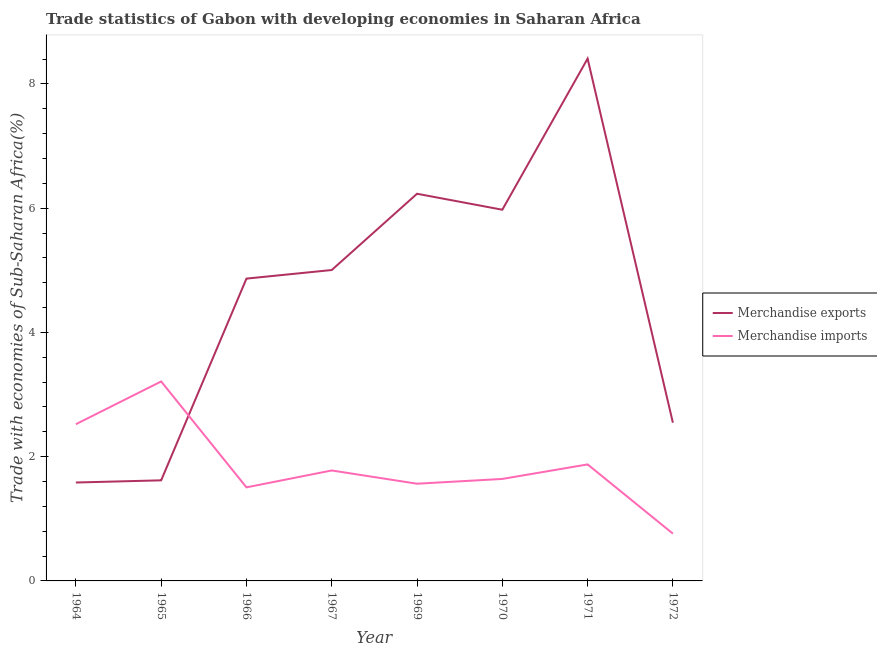How many different coloured lines are there?
Ensure brevity in your answer.  2. Does the line corresponding to merchandise exports intersect with the line corresponding to merchandise imports?
Offer a terse response. Yes. What is the merchandise imports in 1972?
Provide a succinct answer. 0.76. Across all years, what is the maximum merchandise exports?
Give a very brief answer. 8.41. Across all years, what is the minimum merchandise exports?
Your answer should be very brief. 1.58. In which year was the merchandise exports maximum?
Offer a very short reply. 1971. What is the total merchandise imports in the graph?
Keep it short and to the point. 14.86. What is the difference between the merchandise imports in 1964 and that in 1971?
Give a very brief answer. 0.65. What is the difference between the merchandise imports in 1964 and the merchandise exports in 1969?
Provide a succinct answer. -3.71. What is the average merchandise exports per year?
Your response must be concise. 4.53. In the year 1964, what is the difference between the merchandise exports and merchandise imports?
Offer a terse response. -0.94. What is the ratio of the merchandise imports in 1970 to that in 1972?
Your answer should be very brief. 2.16. Is the merchandise exports in 1971 less than that in 1972?
Make the answer very short. No. Is the difference between the merchandise exports in 1966 and 1971 greater than the difference between the merchandise imports in 1966 and 1971?
Ensure brevity in your answer.  No. What is the difference between the highest and the second highest merchandise imports?
Your answer should be compact. 0.69. What is the difference between the highest and the lowest merchandise exports?
Keep it short and to the point. 6.82. In how many years, is the merchandise exports greater than the average merchandise exports taken over all years?
Your answer should be compact. 5. Does the merchandise exports monotonically increase over the years?
Your answer should be compact. No. Is the merchandise imports strictly greater than the merchandise exports over the years?
Provide a short and direct response. No. Is the merchandise imports strictly less than the merchandise exports over the years?
Your answer should be compact. No. Are the values on the major ticks of Y-axis written in scientific E-notation?
Ensure brevity in your answer.  No. Does the graph contain grids?
Keep it short and to the point. No. How many legend labels are there?
Keep it short and to the point. 2. What is the title of the graph?
Offer a terse response. Trade statistics of Gabon with developing economies in Saharan Africa. What is the label or title of the Y-axis?
Give a very brief answer. Trade with economies of Sub-Saharan Africa(%). What is the Trade with economies of Sub-Saharan Africa(%) in Merchandise exports in 1964?
Provide a succinct answer. 1.58. What is the Trade with economies of Sub-Saharan Africa(%) in Merchandise imports in 1964?
Your answer should be very brief. 2.52. What is the Trade with economies of Sub-Saharan Africa(%) of Merchandise exports in 1965?
Your response must be concise. 1.62. What is the Trade with economies of Sub-Saharan Africa(%) of Merchandise imports in 1965?
Make the answer very short. 3.21. What is the Trade with economies of Sub-Saharan Africa(%) in Merchandise exports in 1966?
Your answer should be very brief. 4.87. What is the Trade with economies of Sub-Saharan Africa(%) of Merchandise imports in 1966?
Offer a terse response. 1.51. What is the Trade with economies of Sub-Saharan Africa(%) of Merchandise exports in 1967?
Offer a very short reply. 5. What is the Trade with economies of Sub-Saharan Africa(%) of Merchandise imports in 1967?
Give a very brief answer. 1.78. What is the Trade with economies of Sub-Saharan Africa(%) in Merchandise exports in 1969?
Make the answer very short. 6.23. What is the Trade with economies of Sub-Saharan Africa(%) in Merchandise imports in 1969?
Provide a short and direct response. 1.56. What is the Trade with economies of Sub-Saharan Africa(%) in Merchandise exports in 1970?
Give a very brief answer. 5.97. What is the Trade with economies of Sub-Saharan Africa(%) of Merchandise imports in 1970?
Ensure brevity in your answer.  1.64. What is the Trade with economies of Sub-Saharan Africa(%) of Merchandise exports in 1971?
Give a very brief answer. 8.41. What is the Trade with economies of Sub-Saharan Africa(%) in Merchandise imports in 1971?
Keep it short and to the point. 1.88. What is the Trade with economies of Sub-Saharan Africa(%) of Merchandise exports in 1972?
Offer a very short reply. 2.55. What is the Trade with economies of Sub-Saharan Africa(%) of Merchandise imports in 1972?
Offer a very short reply. 0.76. Across all years, what is the maximum Trade with economies of Sub-Saharan Africa(%) of Merchandise exports?
Ensure brevity in your answer.  8.41. Across all years, what is the maximum Trade with economies of Sub-Saharan Africa(%) in Merchandise imports?
Ensure brevity in your answer.  3.21. Across all years, what is the minimum Trade with economies of Sub-Saharan Africa(%) in Merchandise exports?
Offer a terse response. 1.58. Across all years, what is the minimum Trade with economies of Sub-Saharan Africa(%) in Merchandise imports?
Provide a short and direct response. 0.76. What is the total Trade with economies of Sub-Saharan Africa(%) in Merchandise exports in the graph?
Your response must be concise. 36.23. What is the total Trade with economies of Sub-Saharan Africa(%) of Merchandise imports in the graph?
Your response must be concise. 14.86. What is the difference between the Trade with economies of Sub-Saharan Africa(%) in Merchandise exports in 1964 and that in 1965?
Offer a very short reply. -0.04. What is the difference between the Trade with economies of Sub-Saharan Africa(%) in Merchandise imports in 1964 and that in 1965?
Your answer should be very brief. -0.69. What is the difference between the Trade with economies of Sub-Saharan Africa(%) of Merchandise exports in 1964 and that in 1966?
Make the answer very short. -3.28. What is the difference between the Trade with economies of Sub-Saharan Africa(%) of Merchandise imports in 1964 and that in 1966?
Provide a short and direct response. 1.02. What is the difference between the Trade with economies of Sub-Saharan Africa(%) of Merchandise exports in 1964 and that in 1967?
Give a very brief answer. -3.42. What is the difference between the Trade with economies of Sub-Saharan Africa(%) in Merchandise imports in 1964 and that in 1967?
Make the answer very short. 0.74. What is the difference between the Trade with economies of Sub-Saharan Africa(%) of Merchandise exports in 1964 and that in 1969?
Your answer should be very brief. -4.65. What is the difference between the Trade with economies of Sub-Saharan Africa(%) in Merchandise imports in 1964 and that in 1969?
Offer a terse response. 0.96. What is the difference between the Trade with economies of Sub-Saharan Africa(%) of Merchandise exports in 1964 and that in 1970?
Make the answer very short. -4.39. What is the difference between the Trade with economies of Sub-Saharan Africa(%) of Merchandise imports in 1964 and that in 1970?
Offer a very short reply. 0.88. What is the difference between the Trade with economies of Sub-Saharan Africa(%) in Merchandise exports in 1964 and that in 1971?
Keep it short and to the point. -6.82. What is the difference between the Trade with economies of Sub-Saharan Africa(%) in Merchandise imports in 1964 and that in 1971?
Your answer should be compact. 0.65. What is the difference between the Trade with economies of Sub-Saharan Africa(%) in Merchandise exports in 1964 and that in 1972?
Make the answer very short. -0.96. What is the difference between the Trade with economies of Sub-Saharan Africa(%) of Merchandise imports in 1964 and that in 1972?
Your answer should be compact. 1.76. What is the difference between the Trade with economies of Sub-Saharan Africa(%) in Merchandise exports in 1965 and that in 1966?
Your answer should be very brief. -3.25. What is the difference between the Trade with economies of Sub-Saharan Africa(%) in Merchandise imports in 1965 and that in 1966?
Offer a very short reply. 1.7. What is the difference between the Trade with economies of Sub-Saharan Africa(%) in Merchandise exports in 1965 and that in 1967?
Make the answer very short. -3.39. What is the difference between the Trade with economies of Sub-Saharan Africa(%) of Merchandise imports in 1965 and that in 1967?
Your answer should be very brief. 1.43. What is the difference between the Trade with economies of Sub-Saharan Africa(%) in Merchandise exports in 1965 and that in 1969?
Make the answer very short. -4.61. What is the difference between the Trade with economies of Sub-Saharan Africa(%) of Merchandise imports in 1965 and that in 1969?
Give a very brief answer. 1.65. What is the difference between the Trade with economies of Sub-Saharan Africa(%) in Merchandise exports in 1965 and that in 1970?
Make the answer very short. -4.36. What is the difference between the Trade with economies of Sub-Saharan Africa(%) in Merchandise imports in 1965 and that in 1970?
Make the answer very short. 1.57. What is the difference between the Trade with economies of Sub-Saharan Africa(%) in Merchandise exports in 1965 and that in 1971?
Provide a succinct answer. -6.79. What is the difference between the Trade with economies of Sub-Saharan Africa(%) in Merchandise imports in 1965 and that in 1971?
Your answer should be compact. 1.33. What is the difference between the Trade with economies of Sub-Saharan Africa(%) of Merchandise exports in 1965 and that in 1972?
Your answer should be compact. -0.93. What is the difference between the Trade with economies of Sub-Saharan Africa(%) of Merchandise imports in 1965 and that in 1972?
Make the answer very short. 2.45. What is the difference between the Trade with economies of Sub-Saharan Africa(%) of Merchandise exports in 1966 and that in 1967?
Offer a terse response. -0.14. What is the difference between the Trade with economies of Sub-Saharan Africa(%) of Merchandise imports in 1966 and that in 1967?
Your response must be concise. -0.27. What is the difference between the Trade with economies of Sub-Saharan Africa(%) in Merchandise exports in 1966 and that in 1969?
Keep it short and to the point. -1.37. What is the difference between the Trade with economies of Sub-Saharan Africa(%) of Merchandise imports in 1966 and that in 1969?
Your response must be concise. -0.06. What is the difference between the Trade with economies of Sub-Saharan Africa(%) of Merchandise exports in 1966 and that in 1970?
Offer a very short reply. -1.11. What is the difference between the Trade with economies of Sub-Saharan Africa(%) of Merchandise imports in 1966 and that in 1970?
Your response must be concise. -0.14. What is the difference between the Trade with economies of Sub-Saharan Africa(%) in Merchandise exports in 1966 and that in 1971?
Make the answer very short. -3.54. What is the difference between the Trade with economies of Sub-Saharan Africa(%) in Merchandise imports in 1966 and that in 1971?
Provide a succinct answer. -0.37. What is the difference between the Trade with economies of Sub-Saharan Africa(%) in Merchandise exports in 1966 and that in 1972?
Keep it short and to the point. 2.32. What is the difference between the Trade with economies of Sub-Saharan Africa(%) of Merchandise imports in 1966 and that in 1972?
Keep it short and to the point. 0.74. What is the difference between the Trade with economies of Sub-Saharan Africa(%) of Merchandise exports in 1967 and that in 1969?
Make the answer very short. -1.23. What is the difference between the Trade with economies of Sub-Saharan Africa(%) in Merchandise imports in 1967 and that in 1969?
Your answer should be compact. 0.21. What is the difference between the Trade with economies of Sub-Saharan Africa(%) of Merchandise exports in 1967 and that in 1970?
Give a very brief answer. -0.97. What is the difference between the Trade with economies of Sub-Saharan Africa(%) in Merchandise imports in 1967 and that in 1970?
Ensure brevity in your answer.  0.14. What is the difference between the Trade with economies of Sub-Saharan Africa(%) of Merchandise exports in 1967 and that in 1971?
Offer a very short reply. -3.4. What is the difference between the Trade with economies of Sub-Saharan Africa(%) of Merchandise imports in 1967 and that in 1971?
Provide a succinct answer. -0.1. What is the difference between the Trade with economies of Sub-Saharan Africa(%) in Merchandise exports in 1967 and that in 1972?
Your answer should be very brief. 2.46. What is the difference between the Trade with economies of Sub-Saharan Africa(%) in Merchandise imports in 1967 and that in 1972?
Make the answer very short. 1.02. What is the difference between the Trade with economies of Sub-Saharan Africa(%) of Merchandise exports in 1969 and that in 1970?
Provide a short and direct response. 0.26. What is the difference between the Trade with economies of Sub-Saharan Africa(%) of Merchandise imports in 1969 and that in 1970?
Your response must be concise. -0.08. What is the difference between the Trade with economies of Sub-Saharan Africa(%) of Merchandise exports in 1969 and that in 1971?
Ensure brevity in your answer.  -2.17. What is the difference between the Trade with economies of Sub-Saharan Africa(%) in Merchandise imports in 1969 and that in 1971?
Offer a terse response. -0.31. What is the difference between the Trade with economies of Sub-Saharan Africa(%) in Merchandise exports in 1969 and that in 1972?
Your answer should be very brief. 3.68. What is the difference between the Trade with economies of Sub-Saharan Africa(%) in Merchandise imports in 1969 and that in 1972?
Keep it short and to the point. 0.8. What is the difference between the Trade with economies of Sub-Saharan Africa(%) of Merchandise exports in 1970 and that in 1971?
Your response must be concise. -2.43. What is the difference between the Trade with economies of Sub-Saharan Africa(%) of Merchandise imports in 1970 and that in 1971?
Ensure brevity in your answer.  -0.23. What is the difference between the Trade with economies of Sub-Saharan Africa(%) in Merchandise exports in 1970 and that in 1972?
Keep it short and to the point. 3.43. What is the difference between the Trade with economies of Sub-Saharan Africa(%) of Merchandise imports in 1970 and that in 1972?
Give a very brief answer. 0.88. What is the difference between the Trade with economies of Sub-Saharan Africa(%) of Merchandise exports in 1971 and that in 1972?
Provide a short and direct response. 5.86. What is the difference between the Trade with economies of Sub-Saharan Africa(%) in Merchandise imports in 1971 and that in 1972?
Your answer should be compact. 1.11. What is the difference between the Trade with economies of Sub-Saharan Africa(%) in Merchandise exports in 1964 and the Trade with economies of Sub-Saharan Africa(%) in Merchandise imports in 1965?
Offer a very short reply. -1.63. What is the difference between the Trade with economies of Sub-Saharan Africa(%) in Merchandise exports in 1964 and the Trade with economies of Sub-Saharan Africa(%) in Merchandise imports in 1966?
Give a very brief answer. 0.08. What is the difference between the Trade with economies of Sub-Saharan Africa(%) of Merchandise exports in 1964 and the Trade with economies of Sub-Saharan Africa(%) of Merchandise imports in 1967?
Provide a short and direct response. -0.19. What is the difference between the Trade with economies of Sub-Saharan Africa(%) in Merchandise exports in 1964 and the Trade with economies of Sub-Saharan Africa(%) in Merchandise imports in 1969?
Give a very brief answer. 0.02. What is the difference between the Trade with economies of Sub-Saharan Africa(%) of Merchandise exports in 1964 and the Trade with economies of Sub-Saharan Africa(%) of Merchandise imports in 1970?
Provide a succinct answer. -0.06. What is the difference between the Trade with economies of Sub-Saharan Africa(%) in Merchandise exports in 1964 and the Trade with economies of Sub-Saharan Africa(%) in Merchandise imports in 1971?
Keep it short and to the point. -0.29. What is the difference between the Trade with economies of Sub-Saharan Africa(%) of Merchandise exports in 1964 and the Trade with economies of Sub-Saharan Africa(%) of Merchandise imports in 1972?
Offer a very short reply. 0.82. What is the difference between the Trade with economies of Sub-Saharan Africa(%) of Merchandise exports in 1965 and the Trade with economies of Sub-Saharan Africa(%) of Merchandise imports in 1966?
Provide a short and direct response. 0.11. What is the difference between the Trade with economies of Sub-Saharan Africa(%) in Merchandise exports in 1965 and the Trade with economies of Sub-Saharan Africa(%) in Merchandise imports in 1967?
Ensure brevity in your answer.  -0.16. What is the difference between the Trade with economies of Sub-Saharan Africa(%) of Merchandise exports in 1965 and the Trade with economies of Sub-Saharan Africa(%) of Merchandise imports in 1969?
Your response must be concise. 0.05. What is the difference between the Trade with economies of Sub-Saharan Africa(%) of Merchandise exports in 1965 and the Trade with economies of Sub-Saharan Africa(%) of Merchandise imports in 1970?
Make the answer very short. -0.02. What is the difference between the Trade with economies of Sub-Saharan Africa(%) of Merchandise exports in 1965 and the Trade with economies of Sub-Saharan Africa(%) of Merchandise imports in 1971?
Offer a terse response. -0.26. What is the difference between the Trade with economies of Sub-Saharan Africa(%) in Merchandise exports in 1965 and the Trade with economies of Sub-Saharan Africa(%) in Merchandise imports in 1972?
Provide a succinct answer. 0.86. What is the difference between the Trade with economies of Sub-Saharan Africa(%) of Merchandise exports in 1966 and the Trade with economies of Sub-Saharan Africa(%) of Merchandise imports in 1967?
Keep it short and to the point. 3.09. What is the difference between the Trade with economies of Sub-Saharan Africa(%) of Merchandise exports in 1966 and the Trade with economies of Sub-Saharan Africa(%) of Merchandise imports in 1969?
Provide a short and direct response. 3.3. What is the difference between the Trade with economies of Sub-Saharan Africa(%) in Merchandise exports in 1966 and the Trade with economies of Sub-Saharan Africa(%) in Merchandise imports in 1970?
Give a very brief answer. 3.22. What is the difference between the Trade with economies of Sub-Saharan Africa(%) of Merchandise exports in 1966 and the Trade with economies of Sub-Saharan Africa(%) of Merchandise imports in 1971?
Provide a succinct answer. 2.99. What is the difference between the Trade with economies of Sub-Saharan Africa(%) of Merchandise exports in 1966 and the Trade with economies of Sub-Saharan Africa(%) of Merchandise imports in 1972?
Keep it short and to the point. 4.1. What is the difference between the Trade with economies of Sub-Saharan Africa(%) of Merchandise exports in 1967 and the Trade with economies of Sub-Saharan Africa(%) of Merchandise imports in 1969?
Your response must be concise. 3.44. What is the difference between the Trade with economies of Sub-Saharan Africa(%) in Merchandise exports in 1967 and the Trade with economies of Sub-Saharan Africa(%) in Merchandise imports in 1970?
Provide a succinct answer. 3.36. What is the difference between the Trade with economies of Sub-Saharan Africa(%) of Merchandise exports in 1967 and the Trade with economies of Sub-Saharan Africa(%) of Merchandise imports in 1971?
Your answer should be very brief. 3.13. What is the difference between the Trade with economies of Sub-Saharan Africa(%) of Merchandise exports in 1967 and the Trade with economies of Sub-Saharan Africa(%) of Merchandise imports in 1972?
Ensure brevity in your answer.  4.24. What is the difference between the Trade with economies of Sub-Saharan Africa(%) in Merchandise exports in 1969 and the Trade with economies of Sub-Saharan Africa(%) in Merchandise imports in 1970?
Offer a very short reply. 4.59. What is the difference between the Trade with economies of Sub-Saharan Africa(%) in Merchandise exports in 1969 and the Trade with economies of Sub-Saharan Africa(%) in Merchandise imports in 1971?
Keep it short and to the point. 4.36. What is the difference between the Trade with economies of Sub-Saharan Africa(%) of Merchandise exports in 1969 and the Trade with economies of Sub-Saharan Africa(%) of Merchandise imports in 1972?
Your answer should be compact. 5.47. What is the difference between the Trade with economies of Sub-Saharan Africa(%) in Merchandise exports in 1970 and the Trade with economies of Sub-Saharan Africa(%) in Merchandise imports in 1971?
Your answer should be very brief. 4.1. What is the difference between the Trade with economies of Sub-Saharan Africa(%) in Merchandise exports in 1970 and the Trade with economies of Sub-Saharan Africa(%) in Merchandise imports in 1972?
Make the answer very short. 5.21. What is the difference between the Trade with economies of Sub-Saharan Africa(%) of Merchandise exports in 1971 and the Trade with economies of Sub-Saharan Africa(%) of Merchandise imports in 1972?
Offer a very short reply. 7.65. What is the average Trade with economies of Sub-Saharan Africa(%) in Merchandise exports per year?
Provide a succinct answer. 4.53. What is the average Trade with economies of Sub-Saharan Africa(%) of Merchandise imports per year?
Provide a short and direct response. 1.86. In the year 1964, what is the difference between the Trade with economies of Sub-Saharan Africa(%) of Merchandise exports and Trade with economies of Sub-Saharan Africa(%) of Merchandise imports?
Your response must be concise. -0.94. In the year 1965, what is the difference between the Trade with economies of Sub-Saharan Africa(%) of Merchandise exports and Trade with economies of Sub-Saharan Africa(%) of Merchandise imports?
Ensure brevity in your answer.  -1.59. In the year 1966, what is the difference between the Trade with economies of Sub-Saharan Africa(%) in Merchandise exports and Trade with economies of Sub-Saharan Africa(%) in Merchandise imports?
Your answer should be compact. 3.36. In the year 1967, what is the difference between the Trade with economies of Sub-Saharan Africa(%) of Merchandise exports and Trade with economies of Sub-Saharan Africa(%) of Merchandise imports?
Your response must be concise. 3.23. In the year 1969, what is the difference between the Trade with economies of Sub-Saharan Africa(%) of Merchandise exports and Trade with economies of Sub-Saharan Africa(%) of Merchandise imports?
Make the answer very short. 4.67. In the year 1970, what is the difference between the Trade with economies of Sub-Saharan Africa(%) of Merchandise exports and Trade with economies of Sub-Saharan Africa(%) of Merchandise imports?
Keep it short and to the point. 4.33. In the year 1971, what is the difference between the Trade with economies of Sub-Saharan Africa(%) of Merchandise exports and Trade with economies of Sub-Saharan Africa(%) of Merchandise imports?
Your answer should be very brief. 6.53. In the year 1972, what is the difference between the Trade with economies of Sub-Saharan Africa(%) in Merchandise exports and Trade with economies of Sub-Saharan Africa(%) in Merchandise imports?
Keep it short and to the point. 1.79. What is the ratio of the Trade with economies of Sub-Saharan Africa(%) of Merchandise exports in 1964 to that in 1965?
Your response must be concise. 0.98. What is the ratio of the Trade with economies of Sub-Saharan Africa(%) in Merchandise imports in 1964 to that in 1965?
Your response must be concise. 0.79. What is the ratio of the Trade with economies of Sub-Saharan Africa(%) of Merchandise exports in 1964 to that in 1966?
Offer a very short reply. 0.33. What is the ratio of the Trade with economies of Sub-Saharan Africa(%) of Merchandise imports in 1964 to that in 1966?
Ensure brevity in your answer.  1.68. What is the ratio of the Trade with economies of Sub-Saharan Africa(%) of Merchandise exports in 1964 to that in 1967?
Give a very brief answer. 0.32. What is the ratio of the Trade with economies of Sub-Saharan Africa(%) in Merchandise imports in 1964 to that in 1967?
Make the answer very short. 1.42. What is the ratio of the Trade with economies of Sub-Saharan Africa(%) of Merchandise exports in 1964 to that in 1969?
Provide a succinct answer. 0.25. What is the ratio of the Trade with economies of Sub-Saharan Africa(%) of Merchandise imports in 1964 to that in 1969?
Keep it short and to the point. 1.61. What is the ratio of the Trade with economies of Sub-Saharan Africa(%) of Merchandise exports in 1964 to that in 1970?
Give a very brief answer. 0.27. What is the ratio of the Trade with economies of Sub-Saharan Africa(%) of Merchandise imports in 1964 to that in 1970?
Provide a succinct answer. 1.54. What is the ratio of the Trade with economies of Sub-Saharan Africa(%) in Merchandise exports in 1964 to that in 1971?
Your answer should be compact. 0.19. What is the ratio of the Trade with economies of Sub-Saharan Africa(%) of Merchandise imports in 1964 to that in 1971?
Offer a very short reply. 1.35. What is the ratio of the Trade with economies of Sub-Saharan Africa(%) of Merchandise exports in 1964 to that in 1972?
Your answer should be very brief. 0.62. What is the ratio of the Trade with economies of Sub-Saharan Africa(%) of Merchandise imports in 1964 to that in 1972?
Offer a terse response. 3.31. What is the ratio of the Trade with economies of Sub-Saharan Africa(%) in Merchandise exports in 1965 to that in 1966?
Keep it short and to the point. 0.33. What is the ratio of the Trade with economies of Sub-Saharan Africa(%) in Merchandise imports in 1965 to that in 1966?
Keep it short and to the point. 2.13. What is the ratio of the Trade with economies of Sub-Saharan Africa(%) of Merchandise exports in 1965 to that in 1967?
Offer a very short reply. 0.32. What is the ratio of the Trade with economies of Sub-Saharan Africa(%) of Merchandise imports in 1965 to that in 1967?
Provide a succinct answer. 1.81. What is the ratio of the Trade with economies of Sub-Saharan Africa(%) of Merchandise exports in 1965 to that in 1969?
Your response must be concise. 0.26. What is the ratio of the Trade with economies of Sub-Saharan Africa(%) of Merchandise imports in 1965 to that in 1969?
Your response must be concise. 2.05. What is the ratio of the Trade with economies of Sub-Saharan Africa(%) of Merchandise exports in 1965 to that in 1970?
Ensure brevity in your answer.  0.27. What is the ratio of the Trade with economies of Sub-Saharan Africa(%) of Merchandise imports in 1965 to that in 1970?
Offer a terse response. 1.96. What is the ratio of the Trade with economies of Sub-Saharan Africa(%) in Merchandise exports in 1965 to that in 1971?
Ensure brevity in your answer.  0.19. What is the ratio of the Trade with economies of Sub-Saharan Africa(%) in Merchandise imports in 1965 to that in 1971?
Provide a succinct answer. 1.71. What is the ratio of the Trade with economies of Sub-Saharan Africa(%) in Merchandise exports in 1965 to that in 1972?
Keep it short and to the point. 0.64. What is the ratio of the Trade with economies of Sub-Saharan Africa(%) of Merchandise imports in 1965 to that in 1972?
Offer a very short reply. 4.22. What is the ratio of the Trade with economies of Sub-Saharan Africa(%) of Merchandise exports in 1966 to that in 1967?
Ensure brevity in your answer.  0.97. What is the ratio of the Trade with economies of Sub-Saharan Africa(%) in Merchandise imports in 1966 to that in 1967?
Provide a short and direct response. 0.85. What is the ratio of the Trade with economies of Sub-Saharan Africa(%) in Merchandise exports in 1966 to that in 1969?
Make the answer very short. 0.78. What is the ratio of the Trade with economies of Sub-Saharan Africa(%) of Merchandise imports in 1966 to that in 1969?
Give a very brief answer. 0.96. What is the ratio of the Trade with economies of Sub-Saharan Africa(%) of Merchandise exports in 1966 to that in 1970?
Offer a very short reply. 0.81. What is the ratio of the Trade with economies of Sub-Saharan Africa(%) in Merchandise imports in 1966 to that in 1970?
Keep it short and to the point. 0.92. What is the ratio of the Trade with economies of Sub-Saharan Africa(%) of Merchandise exports in 1966 to that in 1971?
Keep it short and to the point. 0.58. What is the ratio of the Trade with economies of Sub-Saharan Africa(%) in Merchandise imports in 1966 to that in 1971?
Give a very brief answer. 0.8. What is the ratio of the Trade with economies of Sub-Saharan Africa(%) in Merchandise exports in 1966 to that in 1972?
Keep it short and to the point. 1.91. What is the ratio of the Trade with economies of Sub-Saharan Africa(%) in Merchandise imports in 1966 to that in 1972?
Keep it short and to the point. 1.98. What is the ratio of the Trade with economies of Sub-Saharan Africa(%) in Merchandise exports in 1967 to that in 1969?
Give a very brief answer. 0.8. What is the ratio of the Trade with economies of Sub-Saharan Africa(%) of Merchandise imports in 1967 to that in 1969?
Make the answer very short. 1.14. What is the ratio of the Trade with economies of Sub-Saharan Africa(%) of Merchandise exports in 1967 to that in 1970?
Ensure brevity in your answer.  0.84. What is the ratio of the Trade with economies of Sub-Saharan Africa(%) in Merchandise imports in 1967 to that in 1970?
Your response must be concise. 1.08. What is the ratio of the Trade with economies of Sub-Saharan Africa(%) of Merchandise exports in 1967 to that in 1971?
Your response must be concise. 0.6. What is the ratio of the Trade with economies of Sub-Saharan Africa(%) in Merchandise imports in 1967 to that in 1971?
Offer a very short reply. 0.95. What is the ratio of the Trade with economies of Sub-Saharan Africa(%) of Merchandise exports in 1967 to that in 1972?
Make the answer very short. 1.96. What is the ratio of the Trade with economies of Sub-Saharan Africa(%) of Merchandise imports in 1967 to that in 1972?
Keep it short and to the point. 2.34. What is the ratio of the Trade with economies of Sub-Saharan Africa(%) in Merchandise exports in 1969 to that in 1970?
Your response must be concise. 1.04. What is the ratio of the Trade with economies of Sub-Saharan Africa(%) of Merchandise imports in 1969 to that in 1970?
Offer a terse response. 0.95. What is the ratio of the Trade with economies of Sub-Saharan Africa(%) in Merchandise exports in 1969 to that in 1971?
Your answer should be very brief. 0.74. What is the ratio of the Trade with economies of Sub-Saharan Africa(%) of Merchandise imports in 1969 to that in 1971?
Your response must be concise. 0.83. What is the ratio of the Trade with economies of Sub-Saharan Africa(%) in Merchandise exports in 1969 to that in 1972?
Your response must be concise. 2.45. What is the ratio of the Trade with economies of Sub-Saharan Africa(%) in Merchandise imports in 1969 to that in 1972?
Make the answer very short. 2.06. What is the ratio of the Trade with economies of Sub-Saharan Africa(%) in Merchandise exports in 1970 to that in 1971?
Keep it short and to the point. 0.71. What is the ratio of the Trade with economies of Sub-Saharan Africa(%) in Merchandise imports in 1970 to that in 1971?
Offer a very short reply. 0.88. What is the ratio of the Trade with economies of Sub-Saharan Africa(%) of Merchandise exports in 1970 to that in 1972?
Make the answer very short. 2.35. What is the ratio of the Trade with economies of Sub-Saharan Africa(%) of Merchandise imports in 1970 to that in 1972?
Ensure brevity in your answer.  2.16. What is the ratio of the Trade with economies of Sub-Saharan Africa(%) in Merchandise exports in 1971 to that in 1972?
Your answer should be compact. 3.3. What is the ratio of the Trade with economies of Sub-Saharan Africa(%) of Merchandise imports in 1971 to that in 1972?
Provide a short and direct response. 2.46. What is the difference between the highest and the second highest Trade with economies of Sub-Saharan Africa(%) of Merchandise exports?
Offer a terse response. 2.17. What is the difference between the highest and the second highest Trade with economies of Sub-Saharan Africa(%) in Merchandise imports?
Your response must be concise. 0.69. What is the difference between the highest and the lowest Trade with economies of Sub-Saharan Africa(%) in Merchandise exports?
Provide a short and direct response. 6.82. What is the difference between the highest and the lowest Trade with economies of Sub-Saharan Africa(%) of Merchandise imports?
Ensure brevity in your answer.  2.45. 